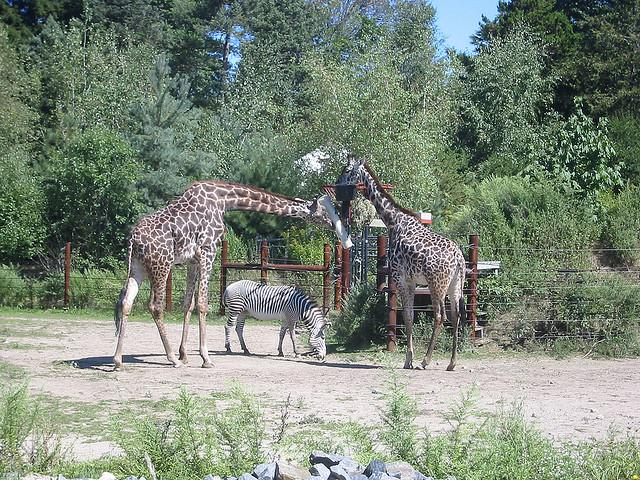What animal is between the giraffes? Please explain your reasoning. zebra. You can tell by the colors and stripes as to what type of animal it is. 